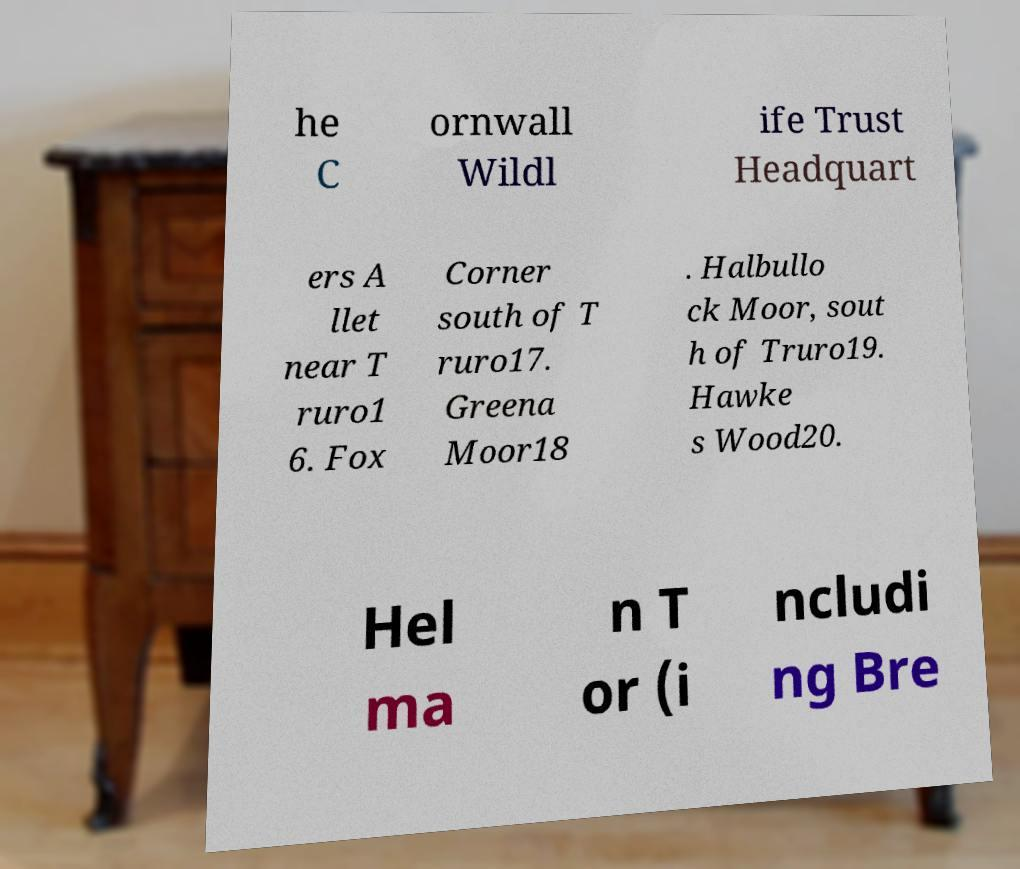What messages or text are displayed in this image? I need them in a readable, typed format. he C ornwall Wildl ife Trust Headquart ers A llet near T ruro1 6. Fox Corner south of T ruro17. Greena Moor18 . Halbullo ck Moor, sout h of Truro19. Hawke s Wood20. Hel ma n T or (i ncludi ng Bre 